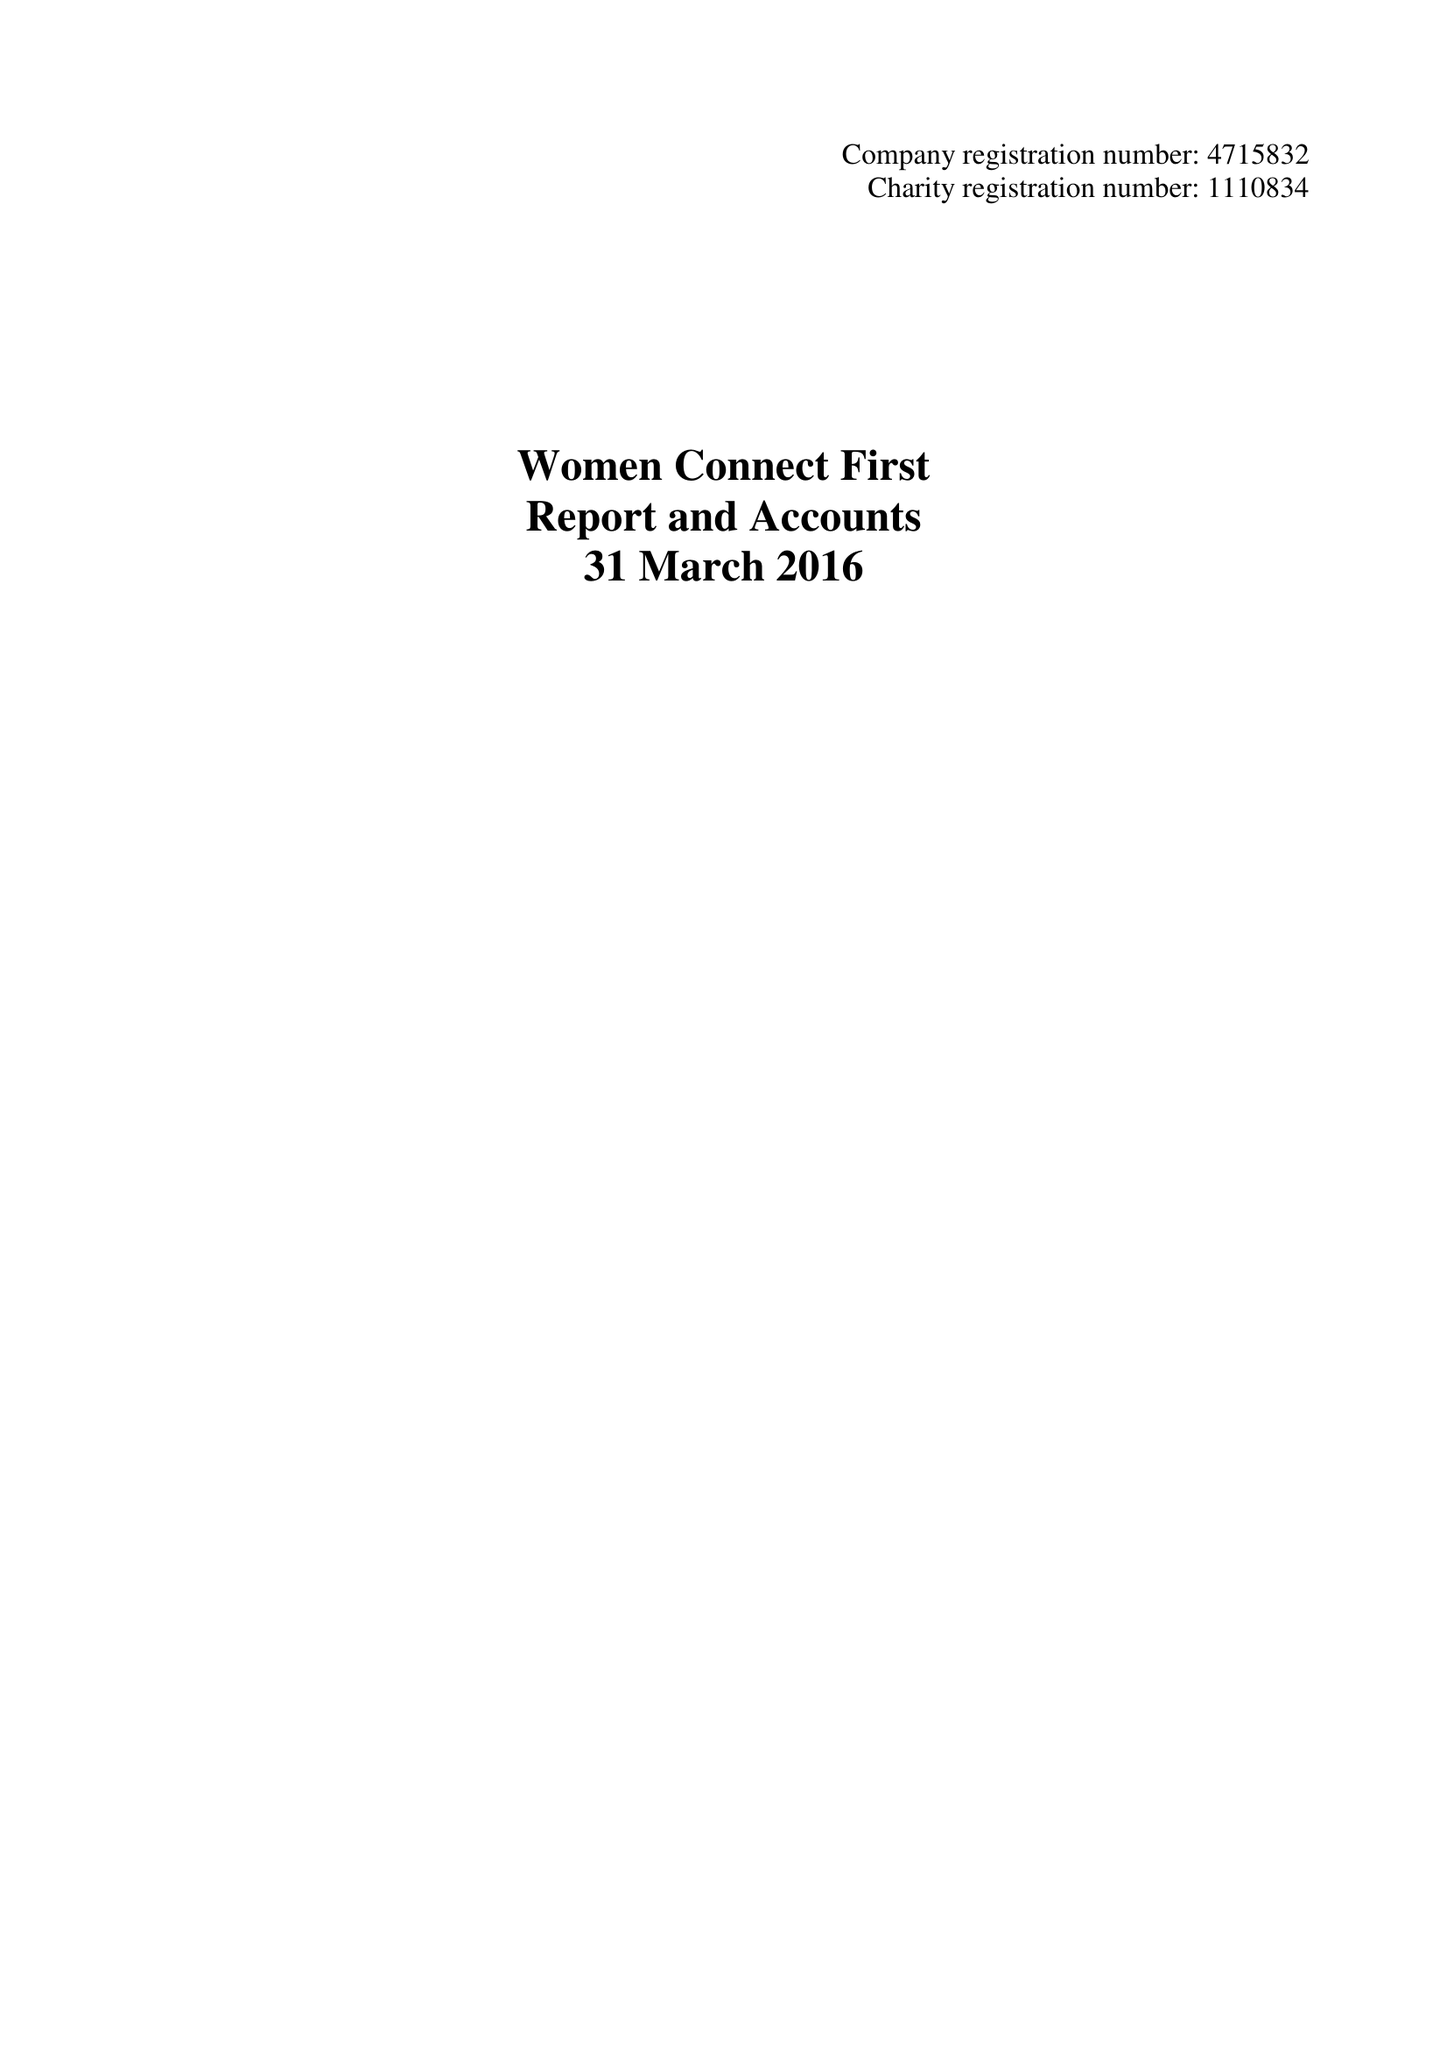What is the value for the address__street_line?
Answer the question using a single word or phrase. 7 NEVILLE STREET 